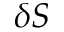Convert formula to latex. <formula><loc_0><loc_0><loc_500><loc_500>\delta S</formula> 